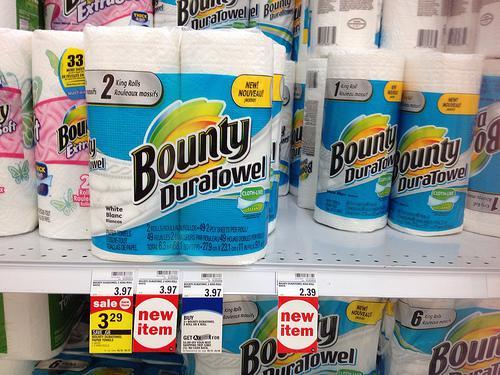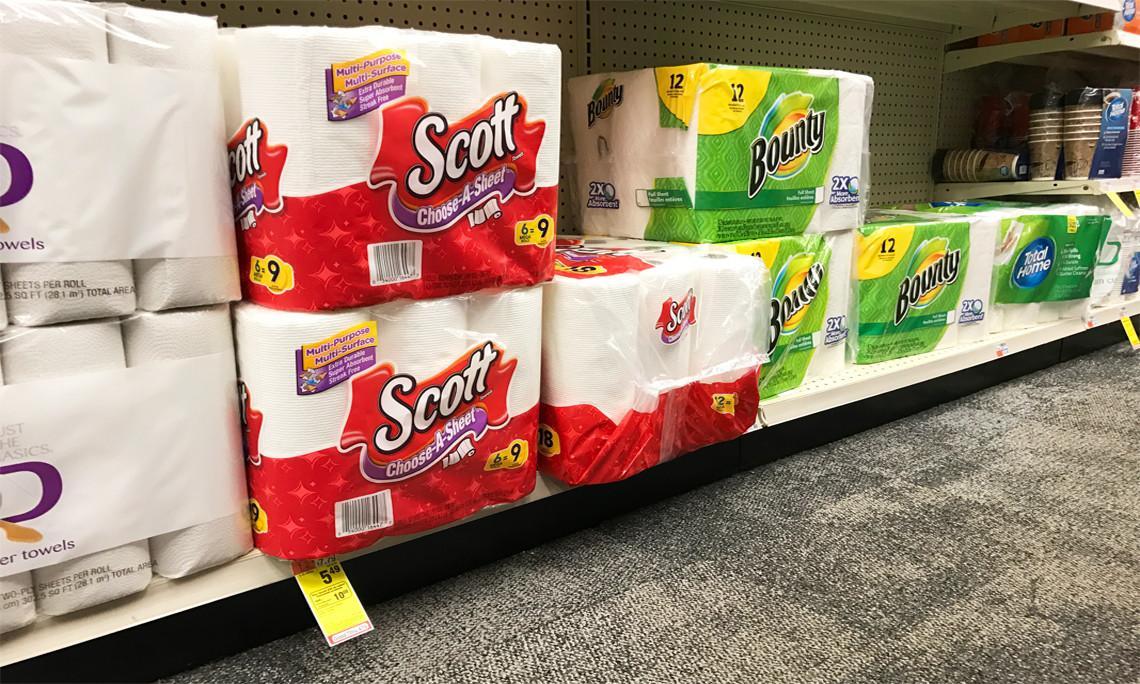The first image is the image on the left, the second image is the image on the right. For the images displayed, is the sentence "at least one image has the price tags on the shelf" factually correct? Answer yes or no. Yes. 